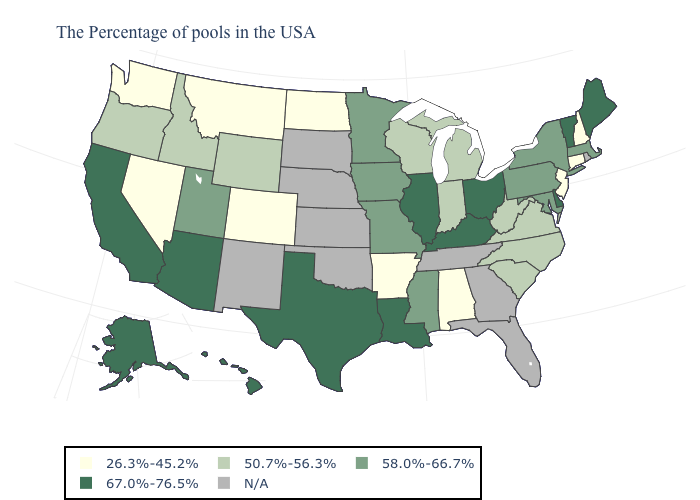Name the states that have a value in the range 50.7%-56.3%?
Be succinct. Virginia, North Carolina, South Carolina, West Virginia, Michigan, Indiana, Wisconsin, Wyoming, Idaho, Oregon. Name the states that have a value in the range 26.3%-45.2%?
Short answer required. New Hampshire, Connecticut, New Jersey, Alabama, Arkansas, North Dakota, Colorado, Montana, Nevada, Washington. Which states have the lowest value in the South?
Answer briefly. Alabama, Arkansas. What is the value of Delaware?
Short answer required. 67.0%-76.5%. What is the highest value in states that border Kentucky?
Write a very short answer. 67.0%-76.5%. Among the states that border Delaware , does New Jersey have the lowest value?
Keep it brief. Yes. Name the states that have a value in the range 50.7%-56.3%?
Concise answer only. Virginia, North Carolina, South Carolina, West Virginia, Michigan, Indiana, Wisconsin, Wyoming, Idaho, Oregon. Does the first symbol in the legend represent the smallest category?
Quick response, please. Yes. What is the value of Massachusetts?
Concise answer only. 58.0%-66.7%. Name the states that have a value in the range N/A?
Give a very brief answer. Rhode Island, Florida, Georgia, Tennessee, Kansas, Nebraska, Oklahoma, South Dakota, New Mexico. Name the states that have a value in the range 58.0%-66.7%?
Concise answer only. Massachusetts, New York, Maryland, Pennsylvania, Mississippi, Missouri, Minnesota, Iowa, Utah. What is the highest value in the USA?
Be succinct. 67.0%-76.5%. Does Minnesota have the highest value in the USA?
Answer briefly. No. 